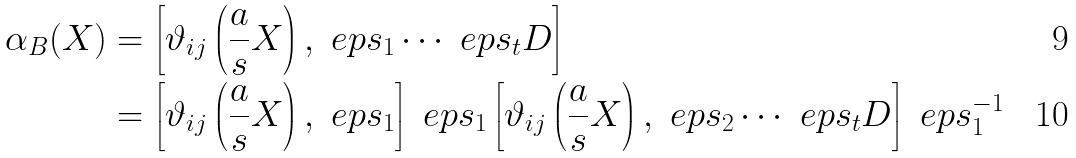<formula> <loc_0><loc_0><loc_500><loc_500>\alpha _ { B } ( X ) & = \left [ \vartheta _ { i j } \left ( \frac { a } { s } X \right ) , \ e p s _ { 1 } \cdots \ e p s _ { t } D \right ] \\ & = \left [ \vartheta _ { i j } \left ( \frac { a } { s } X \right ) , \ e p s _ { 1 } \right ] \ e p s _ { 1 } \left [ \vartheta _ { i j } \left ( \frac { a } { s } X \right ) , \ e p s _ { 2 } \cdots \ e p s _ { t } D \right ] \ e p s _ { 1 } ^ { - 1 }</formula> 